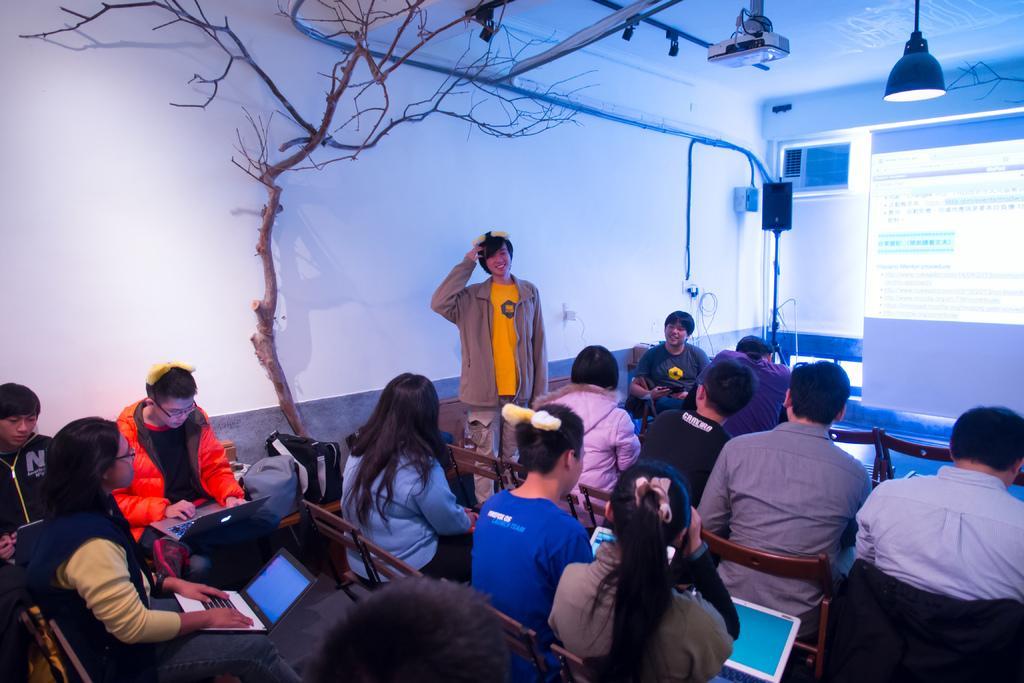Could you give a brief overview of what you see in this image? As we can see in the image there is a white color wall, tree, projector, light, screen and group of people sitting on chairs. Few of them are holding laptops. 